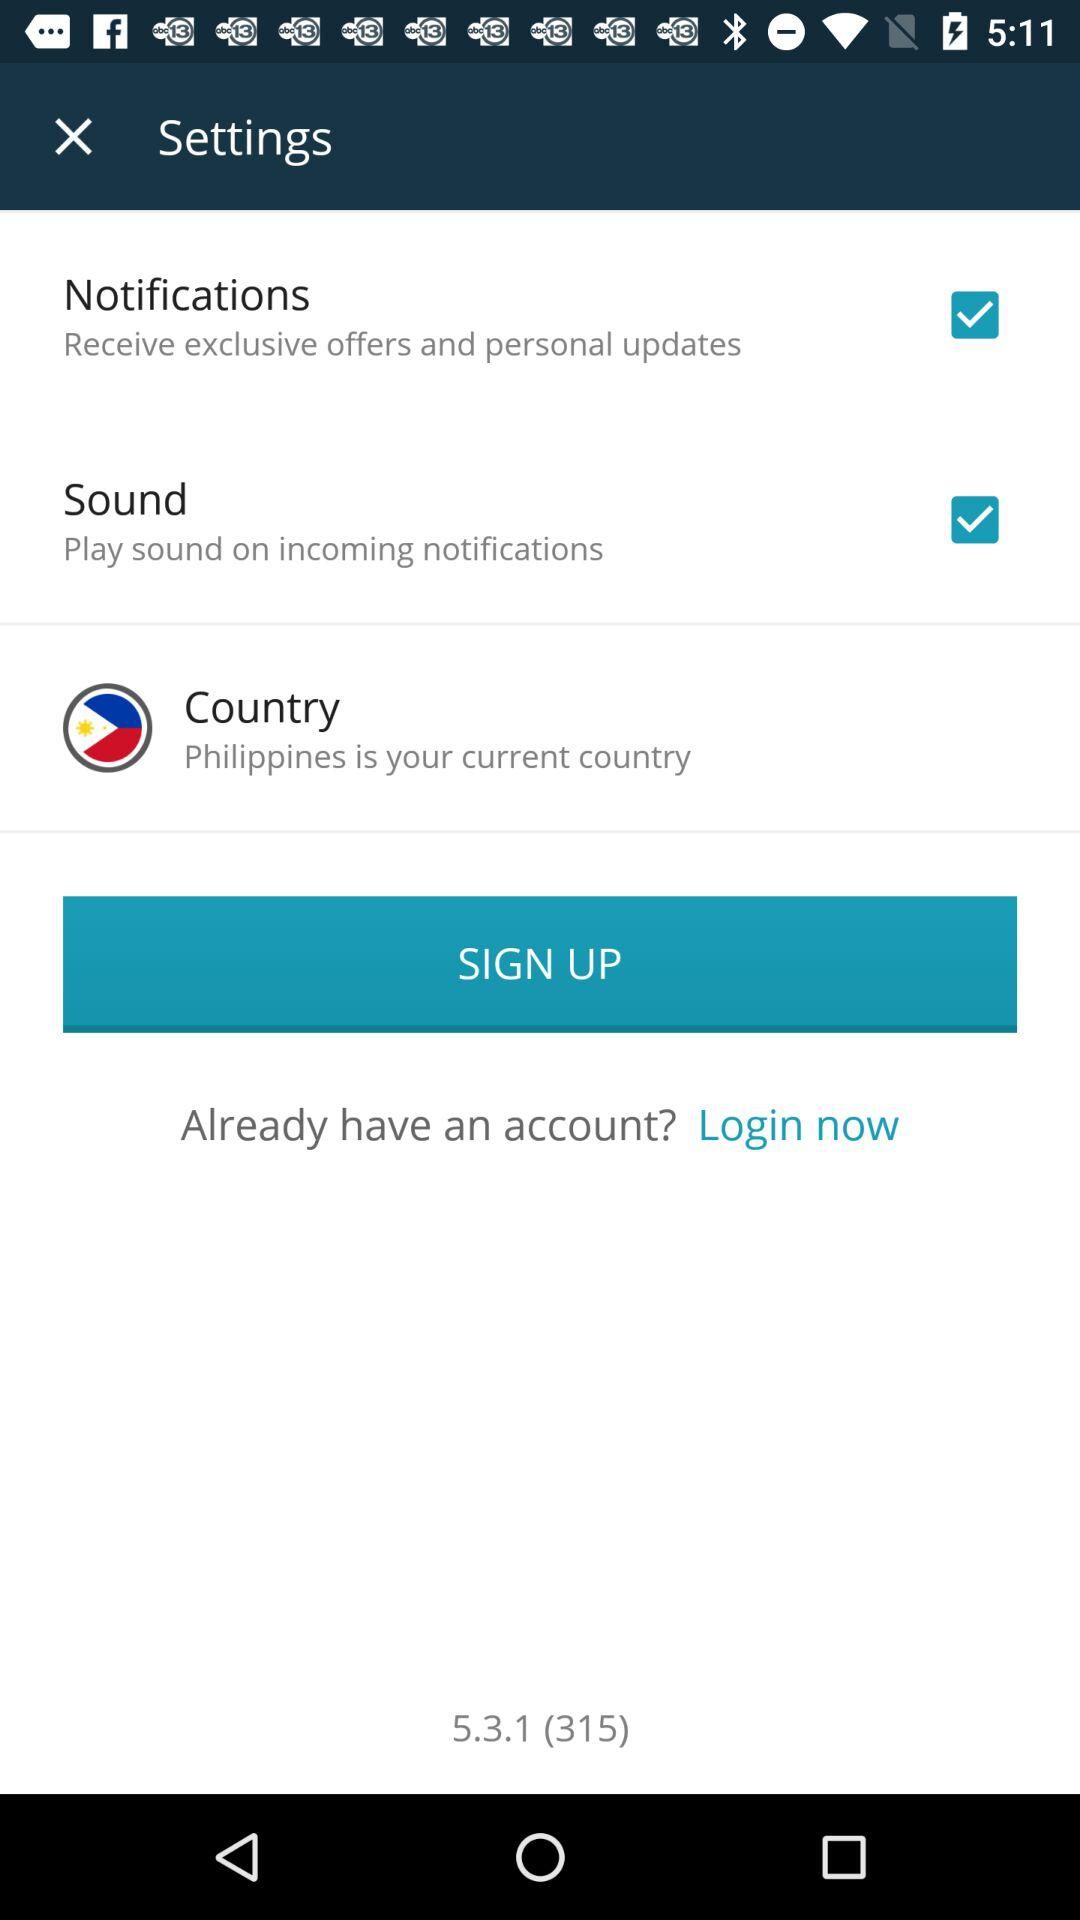How many items can be configured in the settings?
Answer the question using a single word or phrase. 3 